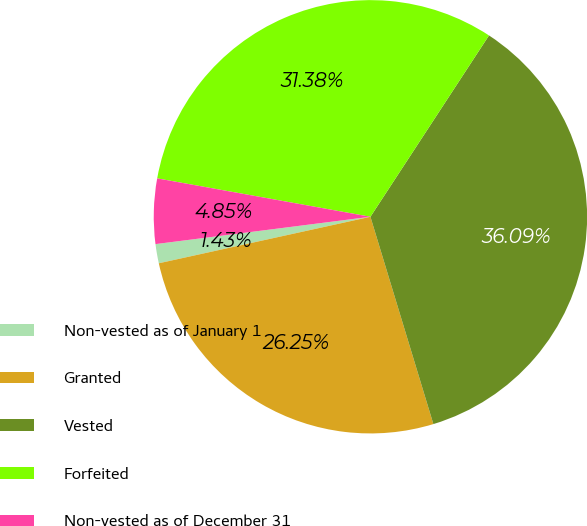Convert chart to OTSL. <chart><loc_0><loc_0><loc_500><loc_500><pie_chart><fcel>Non-vested as of January 1<fcel>Granted<fcel>Vested<fcel>Forfeited<fcel>Non-vested as of December 31<nl><fcel>1.43%<fcel>26.25%<fcel>36.09%<fcel>31.38%<fcel>4.85%<nl></chart> 